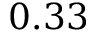Convert formula to latex. <formula><loc_0><loc_0><loc_500><loc_500>0 . 3 3</formula> 